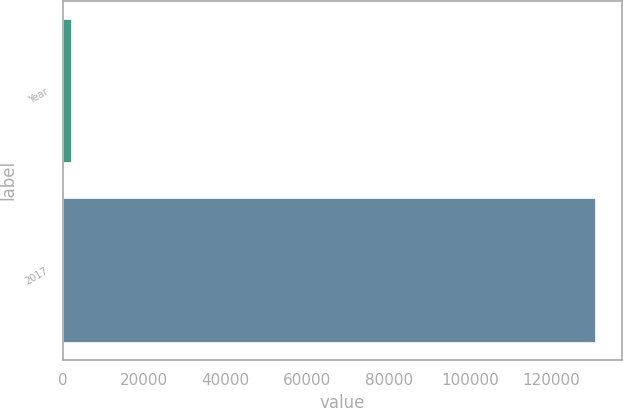Convert chart. <chart><loc_0><loc_0><loc_500><loc_500><bar_chart><fcel>Year<fcel>2017<nl><fcel>2017<fcel>130726<nl></chart> 